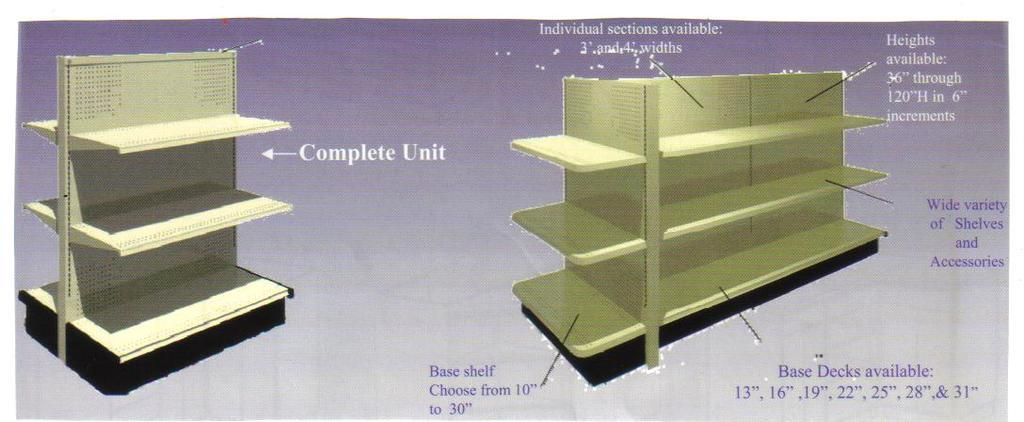<image>
Render a clear and concise summary of the photo. Diagram of white shelf labelled Complete Unit and including dimensions 